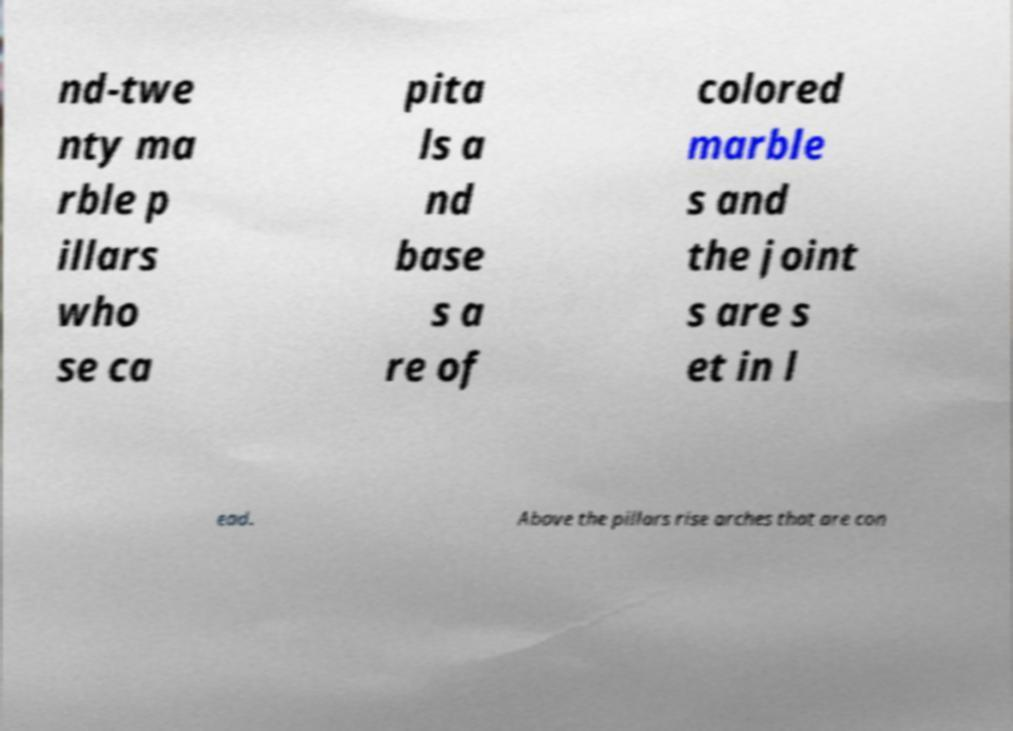What messages or text are displayed in this image? I need them in a readable, typed format. nd-twe nty ma rble p illars who se ca pita ls a nd base s a re of colored marble s and the joint s are s et in l ead. Above the pillars rise arches that are con 